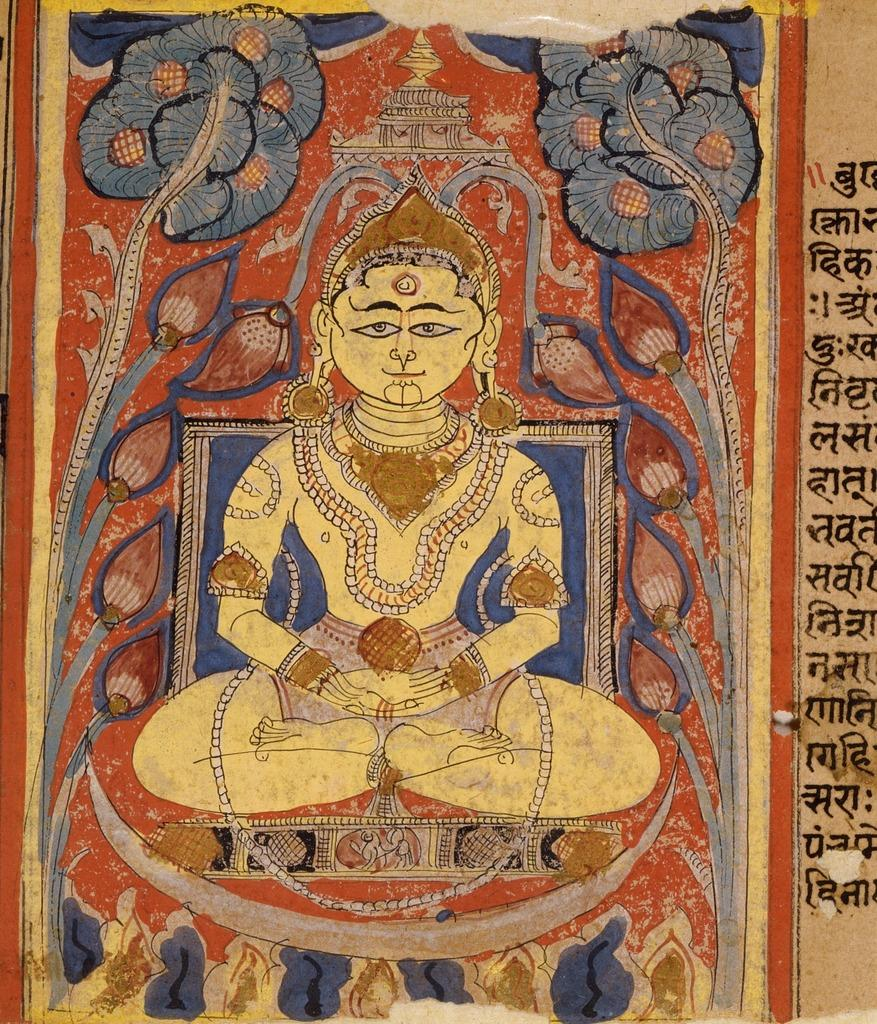What is the main subject of the painting in the image? The painting contains a person sitting. What type of jewelry is the person in the painting wearing? The person in the painting is wearing a neck chain, earrings, and a bracelet. What type of headwear is the person in the painting wearing? The person in the painting is wearing a crown. What other elements are present in the image besides the painting? There is text and some design in the image. How many beads are visible on the person's necklace in the image? There is no mention of beads in the image; the person is wearing a neck chain, but the material or design of the neck chain is not specified. What is the person in the painting doing that causes them to cry in the image? There is no indication in the image that the person in the painting is crying or engaged in any activity that would cause them to cry. 